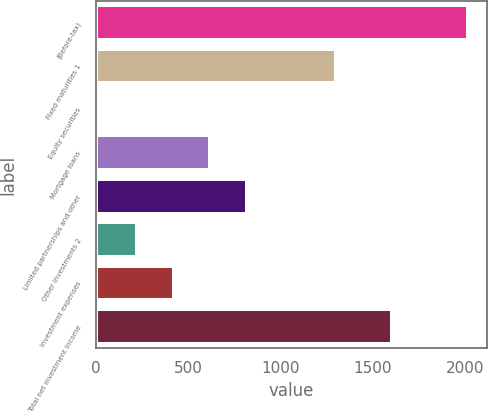Convert chart. <chart><loc_0><loc_0><loc_500><loc_500><bar_chart><fcel>(Before-tax)<fcel>Fixed maturities 1<fcel>Equity securities<fcel>Mortgage loans<fcel>Limited partnerships and other<fcel>Other investments 2<fcel>Investment expenses<fcel>Total net investment income<nl><fcel>2017<fcel>1303<fcel>24<fcel>621.9<fcel>821.2<fcel>223.3<fcel>422.6<fcel>1603<nl></chart> 